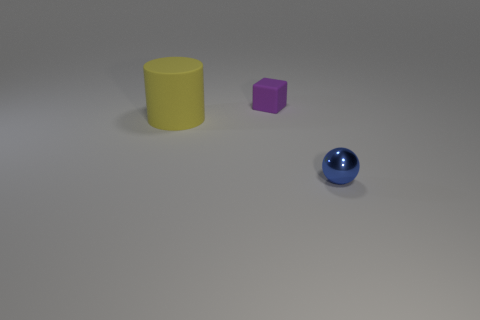Is there anything else that is the same size as the yellow rubber object?
Provide a succinct answer. No. Is there any other thing that has the same material as the cylinder?
Your answer should be very brief. Yes. Is the number of blue shiny spheres that are behind the block less than the number of big gray metallic things?
Provide a succinct answer. No. There is a tiny rubber object; what number of cubes are in front of it?
Your answer should be compact. 0. There is a small thing that is in front of the cylinder; is it the same shape as the tiny thing that is behind the large matte cylinder?
Your answer should be compact. No. There is a object that is both in front of the purple cube and behind the tiny blue ball; what shape is it?
Give a very brief answer. Cylinder. What is the size of the yellow cylinder that is the same material as the small block?
Provide a succinct answer. Large. Is the number of small blue shiny spheres less than the number of big yellow rubber spheres?
Provide a succinct answer. No. There is a small object that is left of the tiny object right of the small thing that is left of the tiny blue metallic ball; what is its material?
Provide a succinct answer. Rubber. Are the tiny thing that is right of the purple matte cube and the object behind the big matte cylinder made of the same material?
Offer a very short reply. No. 